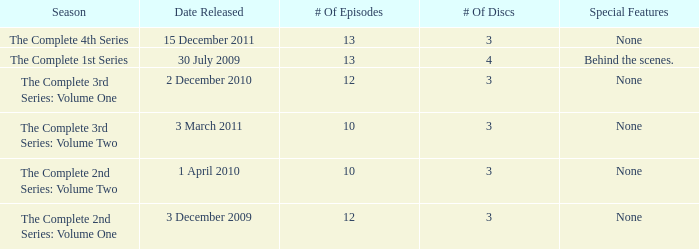Parse the table in full. {'header': ['Season', 'Date Released', '# Of Episodes', '# Of Discs', 'Special Features'], 'rows': [['The Complete 4th Series', '15 December 2011', '13', '3', 'None'], ['The Complete 1st Series', '30 July 2009', '13', '4', 'Behind the scenes.'], ['The Complete 3rd Series: Volume One', '2 December 2010', '12', '3', 'None'], ['The Complete 3rd Series: Volume Two', '3 March 2011', '10', '3', 'None'], ['The Complete 2nd Series: Volume Two', '1 April 2010', '10', '3', 'None'], ['The Complete 2nd Series: Volume One', '3 December 2009', '12', '3', 'None']]} On how many dates was the complete 4th series released? 1.0. 